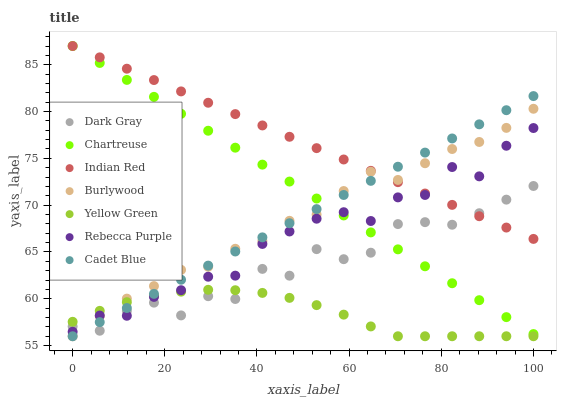Does Yellow Green have the minimum area under the curve?
Answer yes or no. Yes. Does Indian Red have the maximum area under the curve?
Answer yes or no. Yes. Does Burlywood have the minimum area under the curve?
Answer yes or no. No. Does Burlywood have the maximum area under the curve?
Answer yes or no. No. Is Cadet Blue the smoothest?
Answer yes or no. Yes. Is Dark Gray the roughest?
Answer yes or no. Yes. Is Yellow Green the smoothest?
Answer yes or no. No. Is Yellow Green the roughest?
Answer yes or no. No. Does Cadet Blue have the lowest value?
Answer yes or no. Yes. Does Dark Gray have the lowest value?
Answer yes or no. No. Does Indian Red have the highest value?
Answer yes or no. Yes. Does Burlywood have the highest value?
Answer yes or no. No. Is Yellow Green less than Chartreuse?
Answer yes or no. Yes. Is Chartreuse greater than Yellow Green?
Answer yes or no. Yes. Does Cadet Blue intersect Dark Gray?
Answer yes or no. Yes. Is Cadet Blue less than Dark Gray?
Answer yes or no. No. Is Cadet Blue greater than Dark Gray?
Answer yes or no. No. Does Yellow Green intersect Chartreuse?
Answer yes or no. No. 